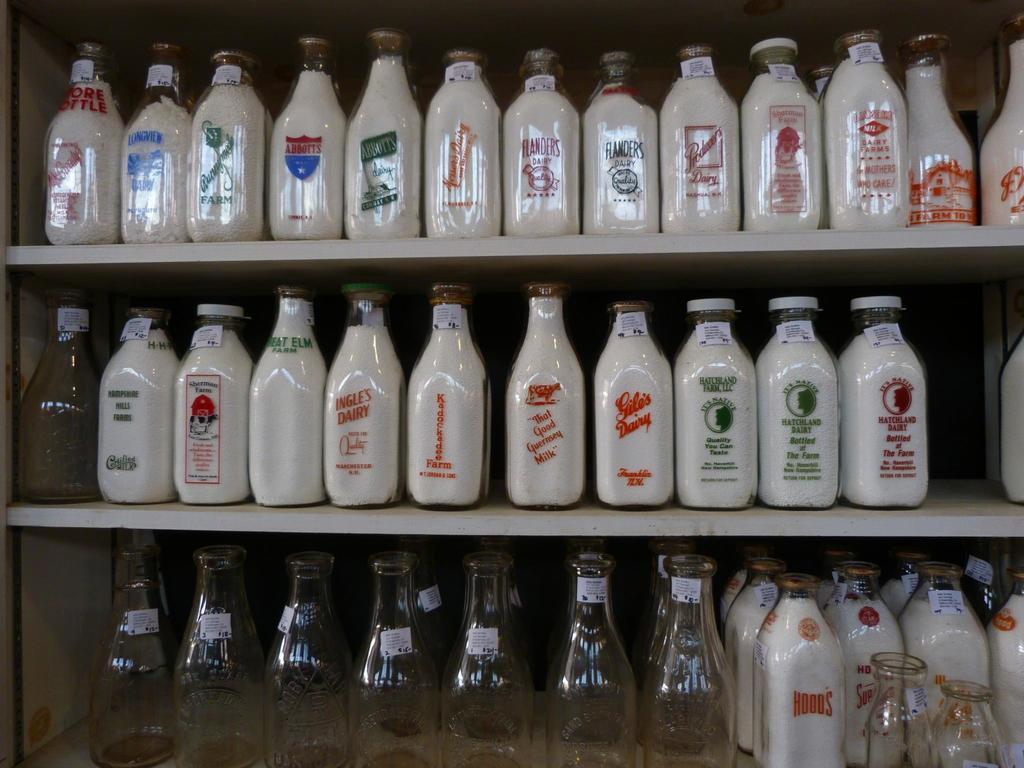<image>
Present a compact description of the photo's key features. Stacks of Milk bottles on 2 shelves with empty bottles below it. 